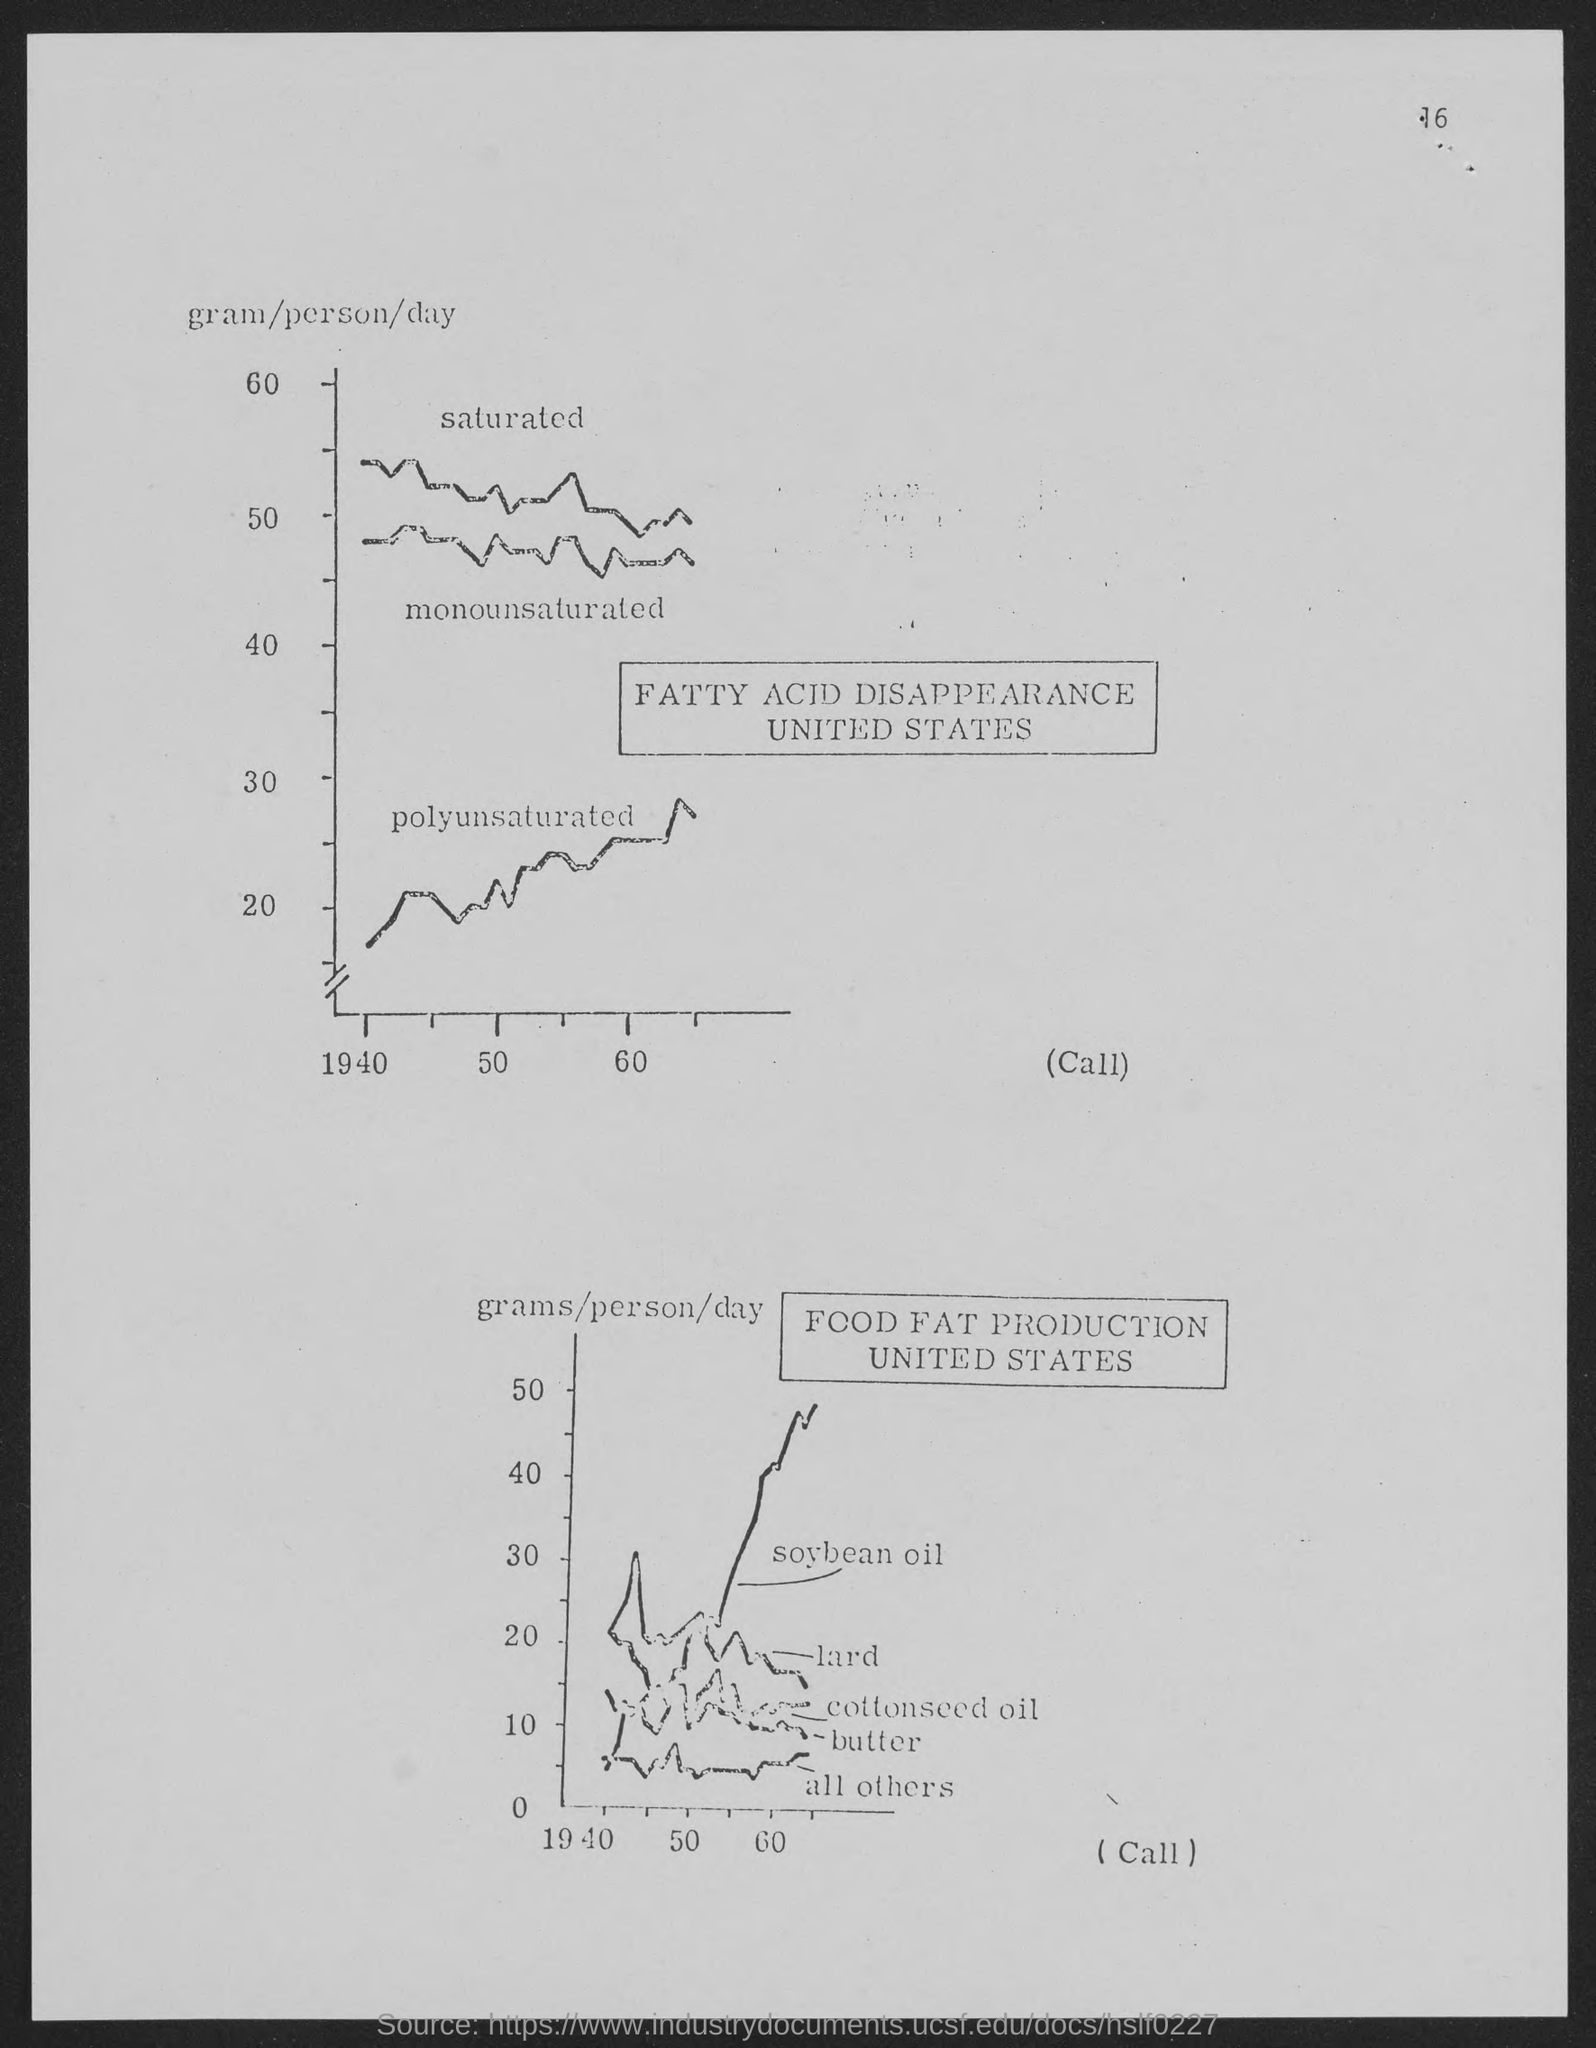Highlight a few significant elements in this photo. The number at the top of the page is 16. 